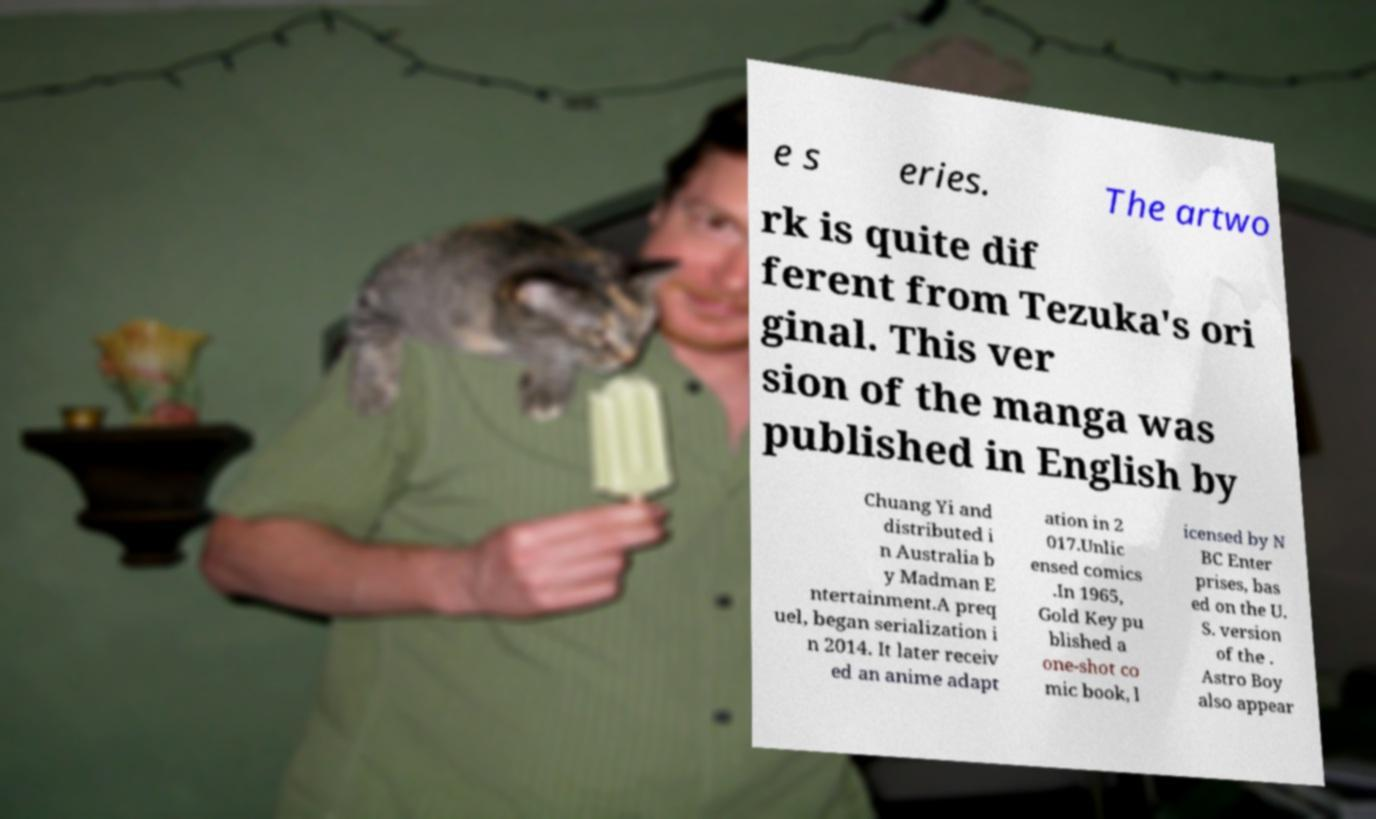Please identify and transcribe the text found in this image. e s eries. The artwo rk is quite dif ferent from Tezuka's ori ginal. This ver sion of the manga was published in English by Chuang Yi and distributed i n Australia b y Madman E ntertainment.A preq uel, began serialization i n 2014. It later receiv ed an anime adapt ation in 2 017.Unlic ensed comics .In 1965, Gold Key pu blished a one-shot co mic book, l icensed by N BC Enter prises, bas ed on the U. S. version of the . Astro Boy also appear 